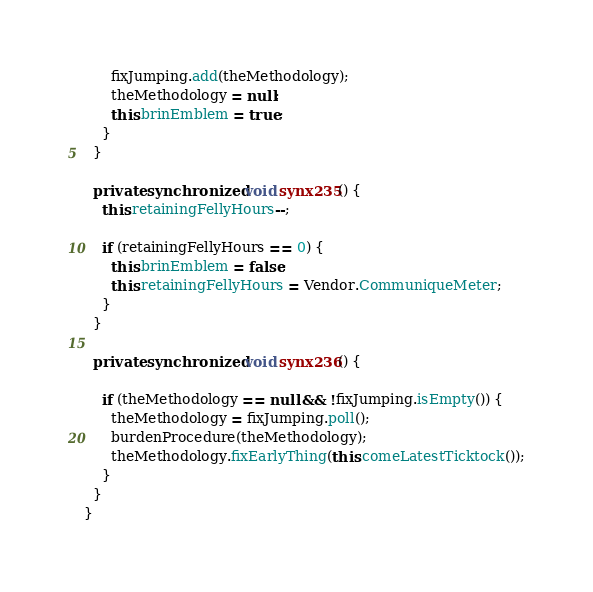<code> <loc_0><loc_0><loc_500><loc_500><_Java_>      fixJumping.add(theMethodology);
      theMethodology = null;
      this.brinEmblem = true;
    }
  }

  private synchronized void synx235() {
    this.retainingFellyHours--;

    if (retainingFellyHours == 0) {
      this.brinEmblem = false;
      this.retainingFellyHours = Vendor.CommuniqueMeter;
    }
  }

  private synchronized void synx236() {

    if (theMethodology == null && !fixJumping.isEmpty()) {
      theMethodology = fixJumping.poll();
      burdenProcedure(theMethodology);
      theMethodology.fixEarlyThing(this.comeLatestTicktock());
    }
  }
}
</code> 